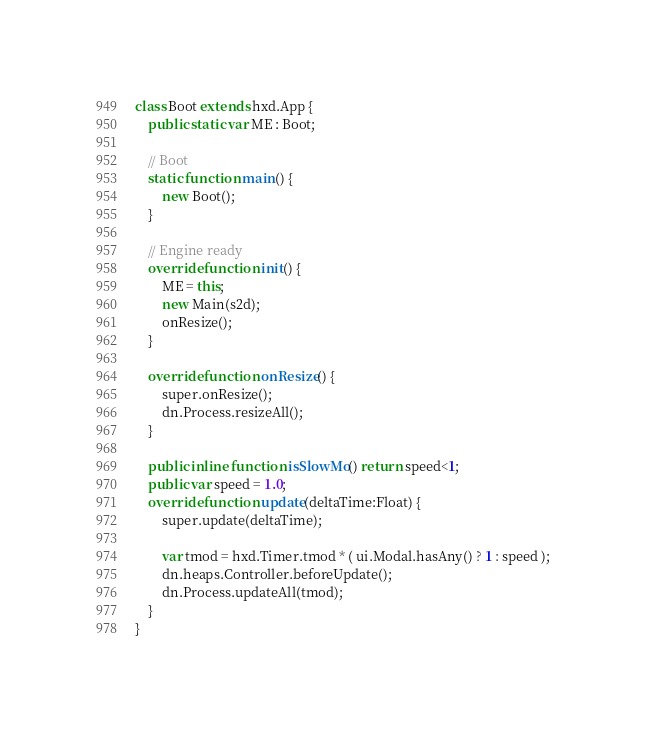Convert code to text. <code><loc_0><loc_0><loc_500><loc_500><_Haxe_>class Boot extends hxd.App {
	public static var ME : Boot;

	// Boot
	static function main() {
		new Boot();
	}

	// Engine ready
	override function init() {
		ME = this;
		new Main(s2d);
		onResize();
	}

	override function onResize() {
		super.onResize();
		dn.Process.resizeAll();
	}

	public inline function isSlowMo() return speed<1;
	public var speed = 1.0;
	override function update(deltaTime:Float) {
		super.update(deltaTime);

		var tmod = hxd.Timer.tmod * ( ui.Modal.hasAny() ? 1 : speed );
		dn.heaps.Controller.beforeUpdate();
		dn.Process.updateAll(tmod);
	}
}

</code> 